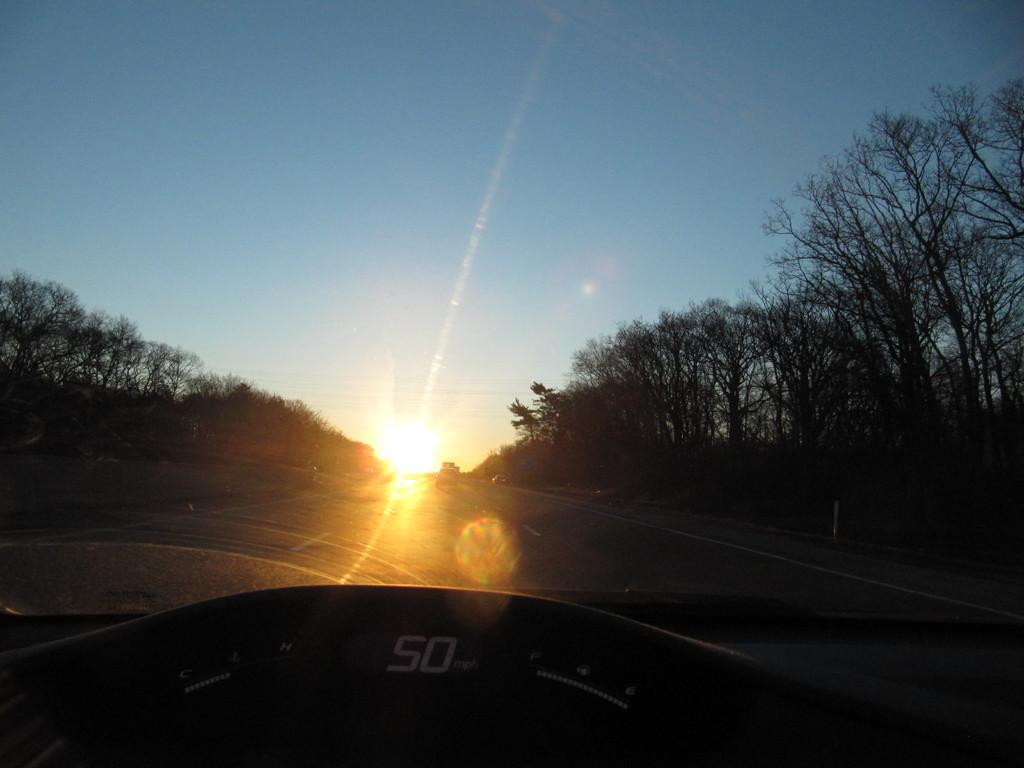Describe this image in one or two sentences. This is inside view of a vehicle and we can see the speedometer and windscreen glass. Through the windscreen glass we can see vehicles on the road, trees on the left and right side and the sky. 